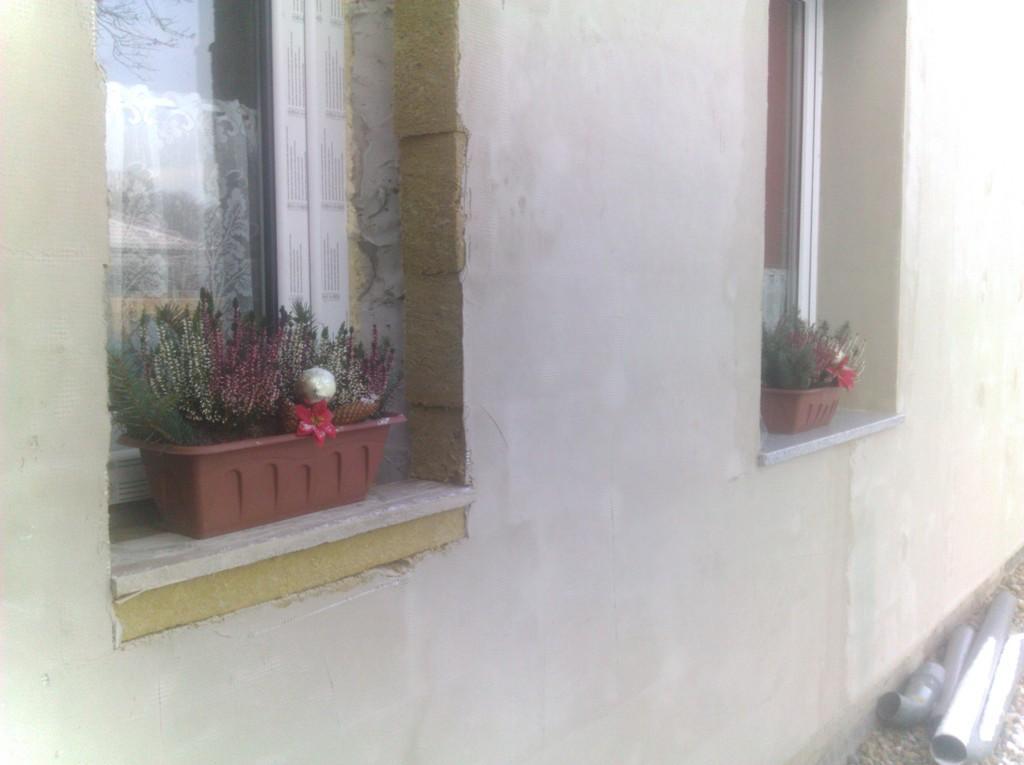In one or two sentences, can you explain what this image depicts? In this image we can see wall, windows and house plants. 